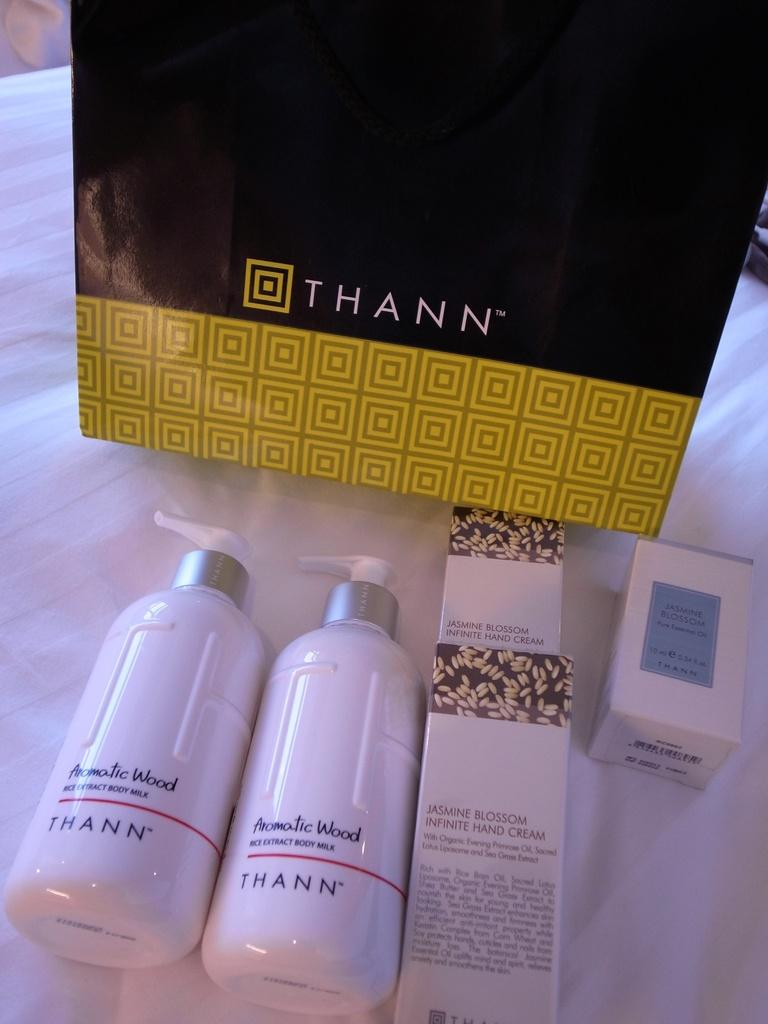<image>
Describe the image concisely. bottles and boxes of skincare products for THANN 